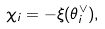<formula> <loc_0><loc_0><loc_500><loc_500>\chi _ { i } = - \xi ( \theta _ { i } ^ { \vee } ) ,</formula> 